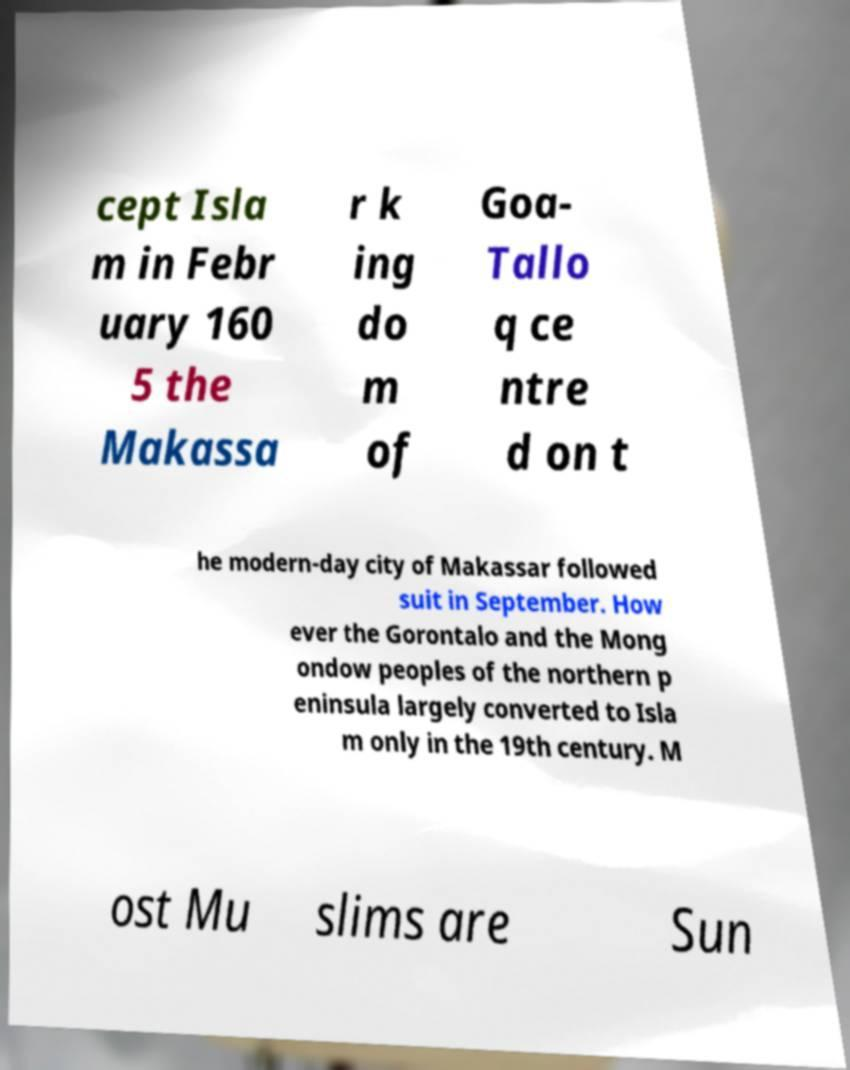Could you assist in decoding the text presented in this image and type it out clearly? cept Isla m in Febr uary 160 5 the Makassa r k ing do m of Goa- Tallo q ce ntre d on t he modern-day city of Makassar followed suit in September. How ever the Gorontalo and the Mong ondow peoples of the northern p eninsula largely converted to Isla m only in the 19th century. M ost Mu slims are Sun 